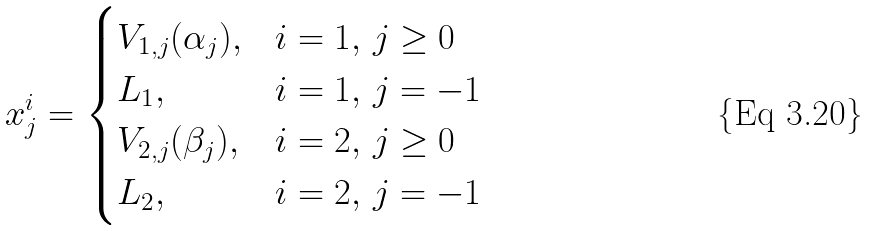<formula> <loc_0><loc_0><loc_500><loc_500>x _ { j } ^ { i } = \begin{cases} V _ { 1 , j } ( \alpha _ { j } ) , & i = 1 , \, j \geq 0 \\ L _ { 1 } , & i = 1 , \, j = - 1 \\ V _ { 2 , j } ( \beta _ { j } ) , & i = 2 , \, j \geq 0 \\ L _ { 2 } , & i = 2 , \, j = - 1 \end{cases}</formula> 